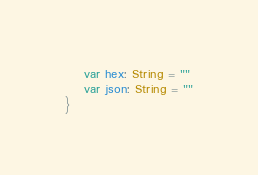Convert code to text. <code><loc_0><loc_0><loc_500><loc_500><_Kotlin_>    var hex: String = ""
    var json: String = ""
}</code> 